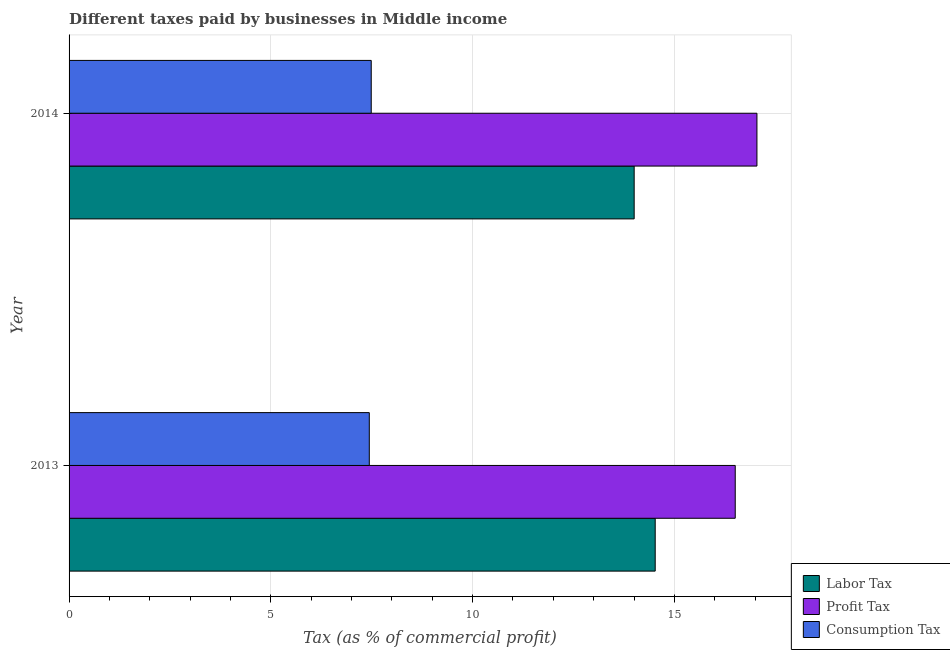How many different coloured bars are there?
Keep it short and to the point. 3. Are the number of bars on each tick of the Y-axis equal?
Make the answer very short. Yes. What is the label of the 1st group of bars from the top?
Make the answer very short. 2014. In how many cases, is the number of bars for a given year not equal to the number of legend labels?
Your answer should be compact. 0. What is the percentage of consumption tax in 2013?
Provide a succinct answer. 7.44. Across all years, what is the maximum percentage of profit tax?
Your response must be concise. 17.05. Across all years, what is the minimum percentage of labor tax?
Your answer should be compact. 14. In which year was the percentage of consumption tax maximum?
Provide a succinct answer. 2014. In which year was the percentage of labor tax minimum?
Keep it short and to the point. 2014. What is the total percentage of labor tax in the graph?
Make the answer very short. 28.53. What is the difference between the percentage of consumption tax in 2013 and that in 2014?
Offer a very short reply. -0.05. What is the difference between the percentage of profit tax in 2013 and the percentage of consumption tax in 2014?
Ensure brevity in your answer.  9.02. What is the average percentage of consumption tax per year?
Offer a terse response. 7.46. In the year 2014, what is the difference between the percentage of profit tax and percentage of labor tax?
Make the answer very short. 3.04. In how many years, is the percentage of consumption tax greater than 6 %?
Ensure brevity in your answer.  2. What is the ratio of the percentage of consumption tax in 2013 to that in 2014?
Ensure brevity in your answer.  0.99. Is the difference between the percentage of consumption tax in 2013 and 2014 greater than the difference between the percentage of profit tax in 2013 and 2014?
Provide a short and direct response. Yes. In how many years, is the percentage of labor tax greater than the average percentage of labor tax taken over all years?
Your answer should be compact. 1. What does the 3rd bar from the top in 2013 represents?
Offer a very short reply. Labor Tax. What does the 3rd bar from the bottom in 2014 represents?
Provide a succinct answer. Consumption Tax. How many bars are there?
Give a very brief answer. 6. How many years are there in the graph?
Keep it short and to the point. 2. What is the difference between two consecutive major ticks on the X-axis?
Offer a terse response. 5. Does the graph contain grids?
Ensure brevity in your answer.  Yes. How many legend labels are there?
Make the answer very short. 3. What is the title of the graph?
Provide a succinct answer. Different taxes paid by businesses in Middle income. Does "Oil" appear as one of the legend labels in the graph?
Keep it short and to the point. No. What is the label or title of the X-axis?
Your response must be concise. Tax (as % of commercial profit). What is the label or title of the Y-axis?
Your answer should be very brief. Year. What is the Tax (as % of commercial profit) in Labor Tax in 2013?
Provide a short and direct response. 14.53. What is the Tax (as % of commercial profit) of Profit Tax in 2013?
Offer a terse response. 16.51. What is the Tax (as % of commercial profit) in Consumption Tax in 2013?
Offer a terse response. 7.44. What is the Tax (as % of commercial profit) in Labor Tax in 2014?
Provide a short and direct response. 14. What is the Tax (as % of commercial profit) of Profit Tax in 2014?
Offer a very short reply. 17.05. What is the Tax (as % of commercial profit) of Consumption Tax in 2014?
Give a very brief answer. 7.49. Across all years, what is the maximum Tax (as % of commercial profit) in Labor Tax?
Offer a very short reply. 14.53. Across all years, what is the maximum Tax (as % of commercial profit) of Profit Tax?
Provide a short and direct response. 17.05. Across all years, what is the maximum Tax (as % of commercial profit) in Consumption Tax?
Give a very brief answer. 7.49. Across all years, what is the minimum Tax (as % of commercial profit) in Labor Tax?
Give a very brief answer. 14. Across all years, what is the minimum Tax (as % of commercial profit) in Profit Tax?
Your response must be concise. 16.51. Across all years, what is the minimum Tax (as % of commercial profit) of Consumption Tax?
Your answer should be very brief. 7.44. What is the total Tax (as % of commercial profit) of Labor Tax in the graph?
Offer a very short reply. 28.53. What is the total Tax (as % of commercial profit) in Profit Tax in the graph?
Make the answer very short. 33.56. What is the total Tax (as % of commercial profit) in Consumption Tax in the graph?
Your answer should be very brief. 14.93. What is the difference between the Tax (as % of commercial profit) in Labor Tax in 2013 and that in 2014?
Offer a very short reply. 0.52. What is the difference between the Tax (as % of commercial profit) in Profit Tax in 2013 and that in 2014?
Provide a short and direct response. -0.54. What is the difference between the Tax (as % of commercial profit) of Consumption Tax in 2013 and that in 2014?
Offer a terse response. -0.05. What is the difference between the Tax (as % of commercial profit) of Labor Tax in 2013 and the Tax (as % of commercial profit) of Profit Tax in 2014?
Offer a terse response. -2.52. What is the difference between the Tax (as % of commercial profit) of Labor Tax in 2013 and the Tax (as % of commercial profit) of Consumption Tax in 2014?
Provide a short and direct response. 7.04. What is the difference between the Tax (as % of commercial profit) of Profit Tax in 2013 and the Tax (as % of commercial profit) of Consumption Tax in 2014?
Offer a very short reply. 9.02. What is the average Tax (as % of commercial profit) in Labor Tax per year?
Provide a short and direct response. 14.27. What is the average Tax (as % of commercial profit) in Profit Tax per year?
Your response must be concise. 16.78. What is the average Tax (as % of commercial profit) of Consumption Tax per year?
Give a very brief answer. 7.46. In the year 2013, what is the difference between the Tax (as % of commercial profit) of Labor Tax and Tax (as % of commercial profit) of Profit Tax?
Your response must be concise. -1.98. In the year 2013, what is the difference between the Tax (as % of commercial profit) of Labor Tax and Tax (as % of commercial profit) of Consumption Tax?
Ensure brevity in your answer.  7.09. In the year 2013, what is the difference between the Tax (as % of commercial profit) of Profit Tax and Tax (as % of commercial profit) of Consumption Tax?
Keep it short and to the point. 9.07. In the year 2014, what is the difference between the Tax (as % of commercial profit) in Labor Tax and Tax (as % of commercial profit) in Profit Tax?
Your answer should be compact. -3.04. In the year 2014, what is the difference between the Tax (as % of commercial profit) of Labor Tax and Tax (as % of commercial profit) of Consumption Tax?
Offer a terse response. 6.52. In the year 2014, what is the difference between the Tax (as % of commercial profit) of Profit Tax and Tax (as % of commercial profit) of Consumption Tax?
Your response must be concise. 9.56. What is the ratio of the Tax (as % of commercial profit) in Labor Tax in 2013 to that in 2014?
Keep it short and to the point. 1.04. What is the ratio of the Tax (as % of commercial profit) in Profit Tax in 2013 to that in 2014?
Your answer should be compact. 0.97. What is the ratio of the Tax (as % of commercial profit) in Consumption Tax in 2013 to that in 2014?
Offer a very short reply. 0.99. What is the difference between the highest and the second highest Tax (as % of commercial profit) of Labor Tax?
Your response must be concise. 0.52. What is the difference between the highest and the second highest Tax (as % of commercial profit) of Profit Tax?
Provide a short and direct response. 0.54. What is the difference between the highest and the second highest Tax (as % of commercial profit) of Consumption Tax?
Give a very brief answer. 0.05. What is the difference between the highest and the lowest Tax (as % of commercial profit) in Labor Tax?
Your answer should be compact. 0.52. What is the difference between the highest and the lowest Tax (as % of commercial profit) of Profit Tax?
Keep it short and to the point. 0.54. What is the difference between the highest and the lowest Tax (as % of commercial profit) of Consumption Tax?
Your answer should be compact. 0.05. 